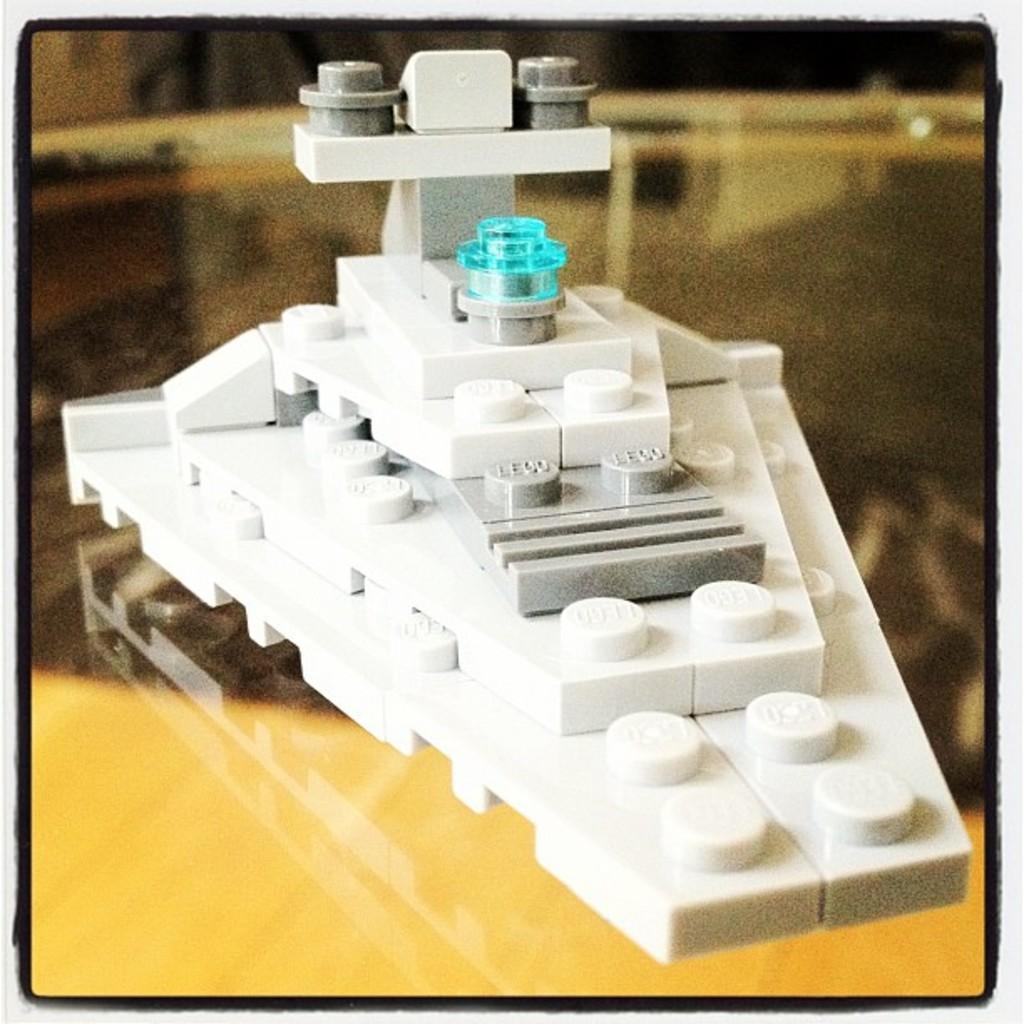What is the main subject of the image? The main subject of the image is an object made with lego. Can you describe the surface on which the lego object is placed? The lego object is on a glass surface. What can be observed about the background of the image? The background of the image is blurred. What language is the woman speaking in the image? There is no woman present in the image, and therefore no language being spoken. 